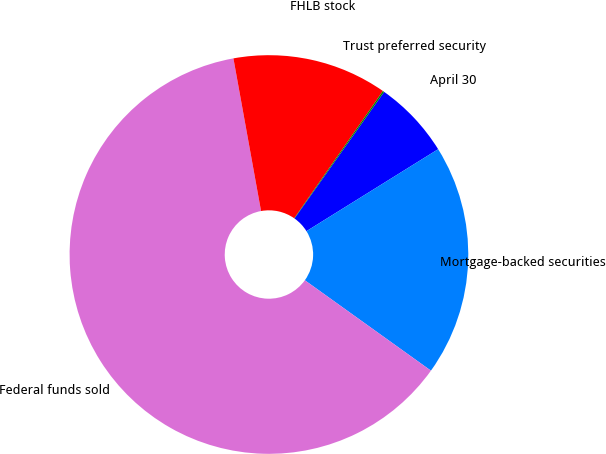Convert chart. <chart><loc_0><loc_0><loc_500><loc_500><pie_chart><fcel>April 30<fcel>Mortgage-backed securities<fcel>Federal funds sold<fcel>FHLB stock<fcel>Trust preferred security<nl><fcel>6.33%<fcel>18.76%<fcel>62.25%<fcel>12.54%<fcel>0.12%<nl></chart> 